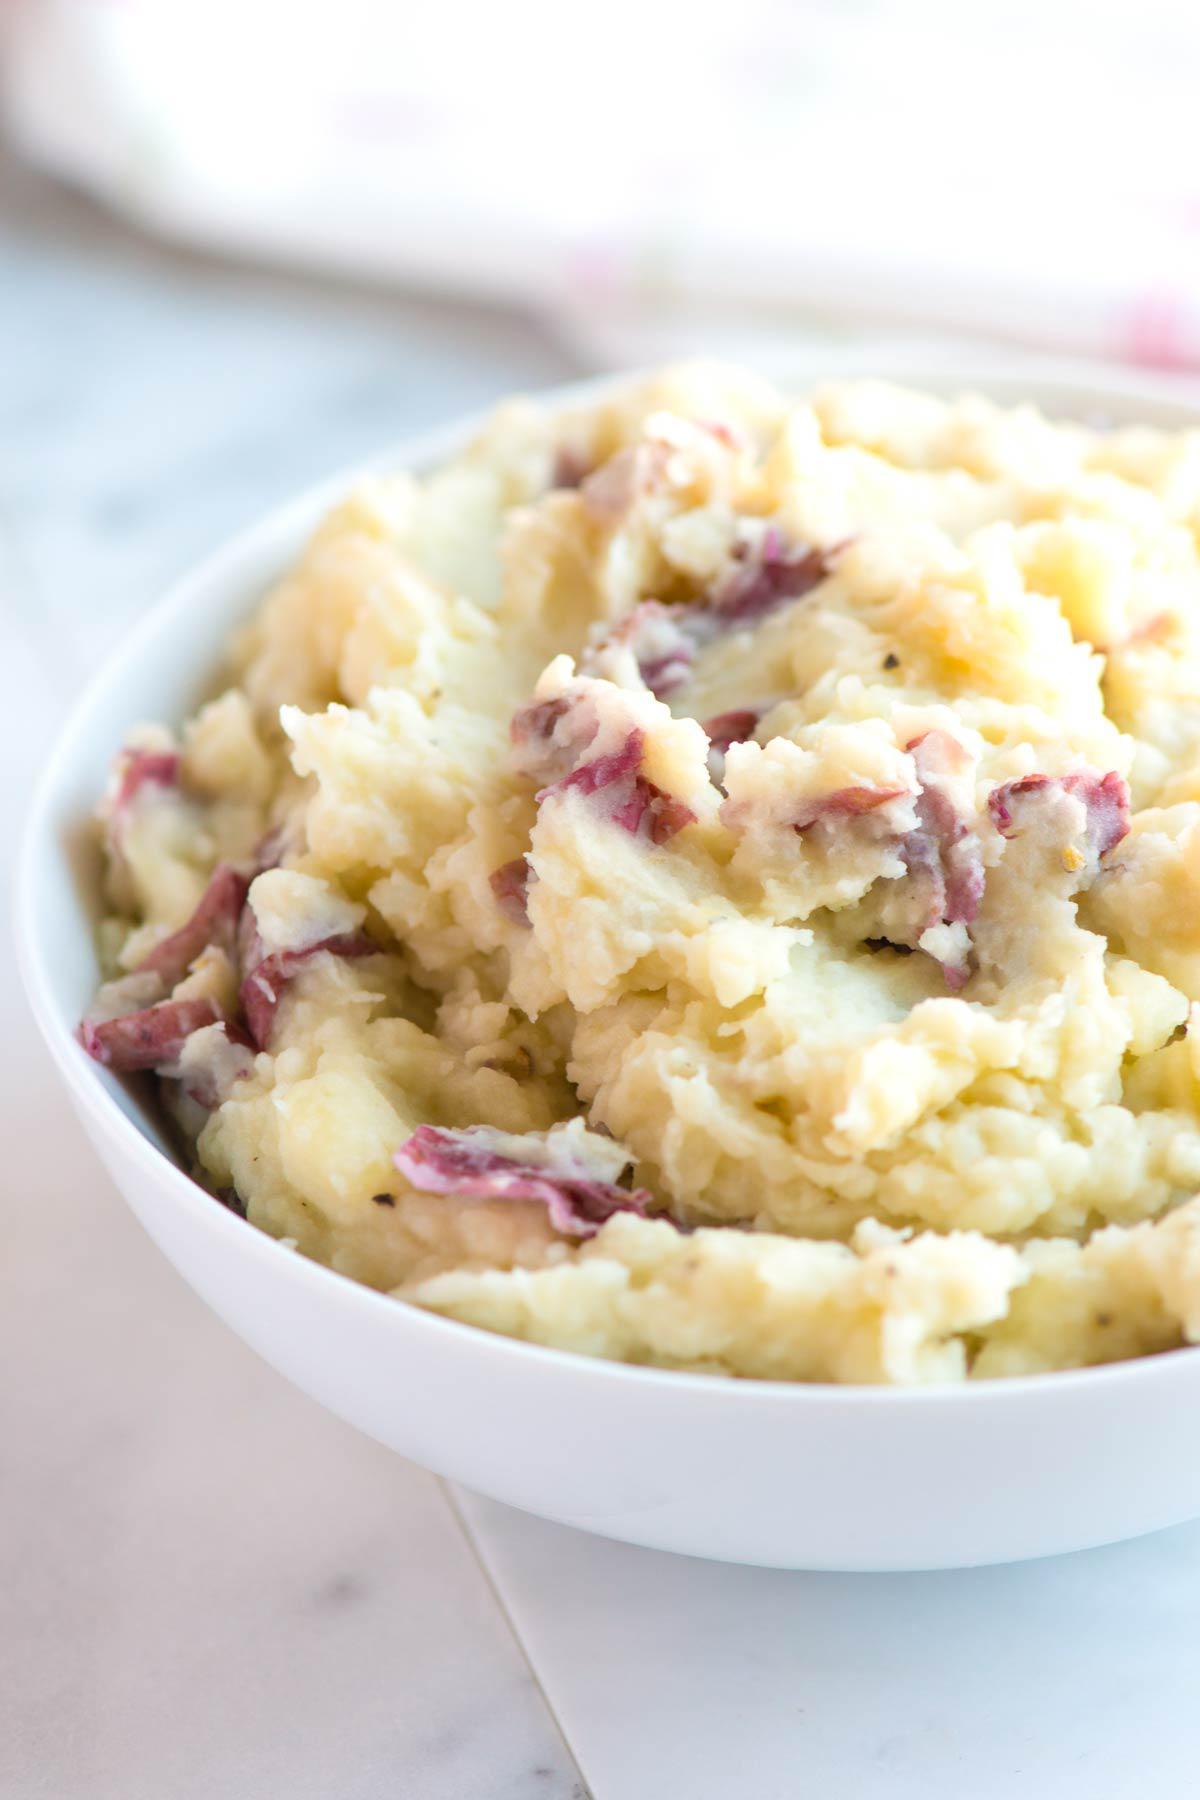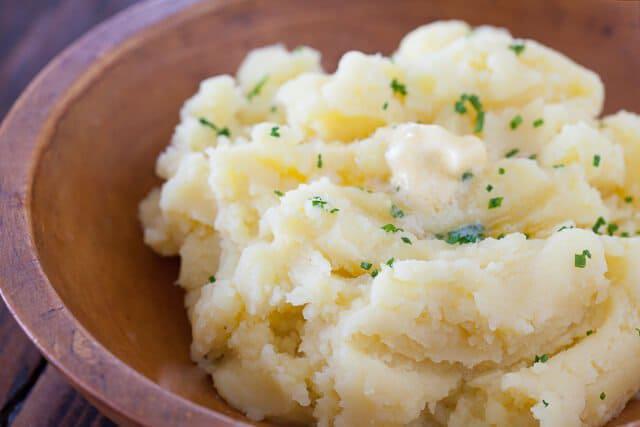The first image is the image on the left, the second image is the image on the right. Examine the images to the left and right. Is the description "The mashed potato bowl on the right contains a serving utensil." accurate? Answer yes or no. No. The first image is the image on the left, the second image is the image on the right. Examine the images to the left and right. Is the description "There is one spoon shown." accurate? Answer yes or no. No. 